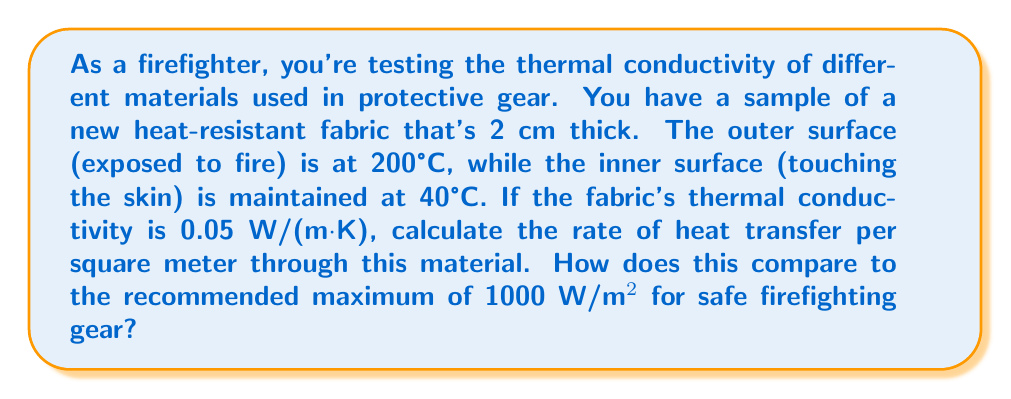What is the answer to this math problem? Let's approach this step-by-step using the heat equation:

1) The heat equation for steady-state conduction in one dimension is:

   $$q = -k \frac{dT}{dx}$$

   Where:
   $q$ = heat flux (W/m²)
   $k$ = thermal conductivity (W/(m·K))
   $\frac{dT}{dx}$ = temperature gradient (K/m)

2) For a constant thermal conductivity and linear temperature distribution:

   $$q = k \frac{T_2 - T_1}{L}$$

   Where:
   $T_2$ = hot side temperature (200°C = 473.15 K)
   $T_1$ = cool side temperature (40°C = 313.15 K)
   $L$ = material thickness (0.02 m)

3) Plugging in the values:

   $$q = 0.05 \frac{473.15 - 313.15}{0.02}$$

4) Calculating:

   $$q = 0.05 \frac{160}{0.02} = 0.05 \cdot 8000 = 400 \text{ W/m²}$$

5) Comparing to the recommended maximum:

   $400 \text{ W/m²} < 1000 \text{ W/m²}$

   The heat transfer rate is well below the recommended maximum, indicating that this material provides good thermal protection for firefighting gear.
Answer: 400 W/m² 